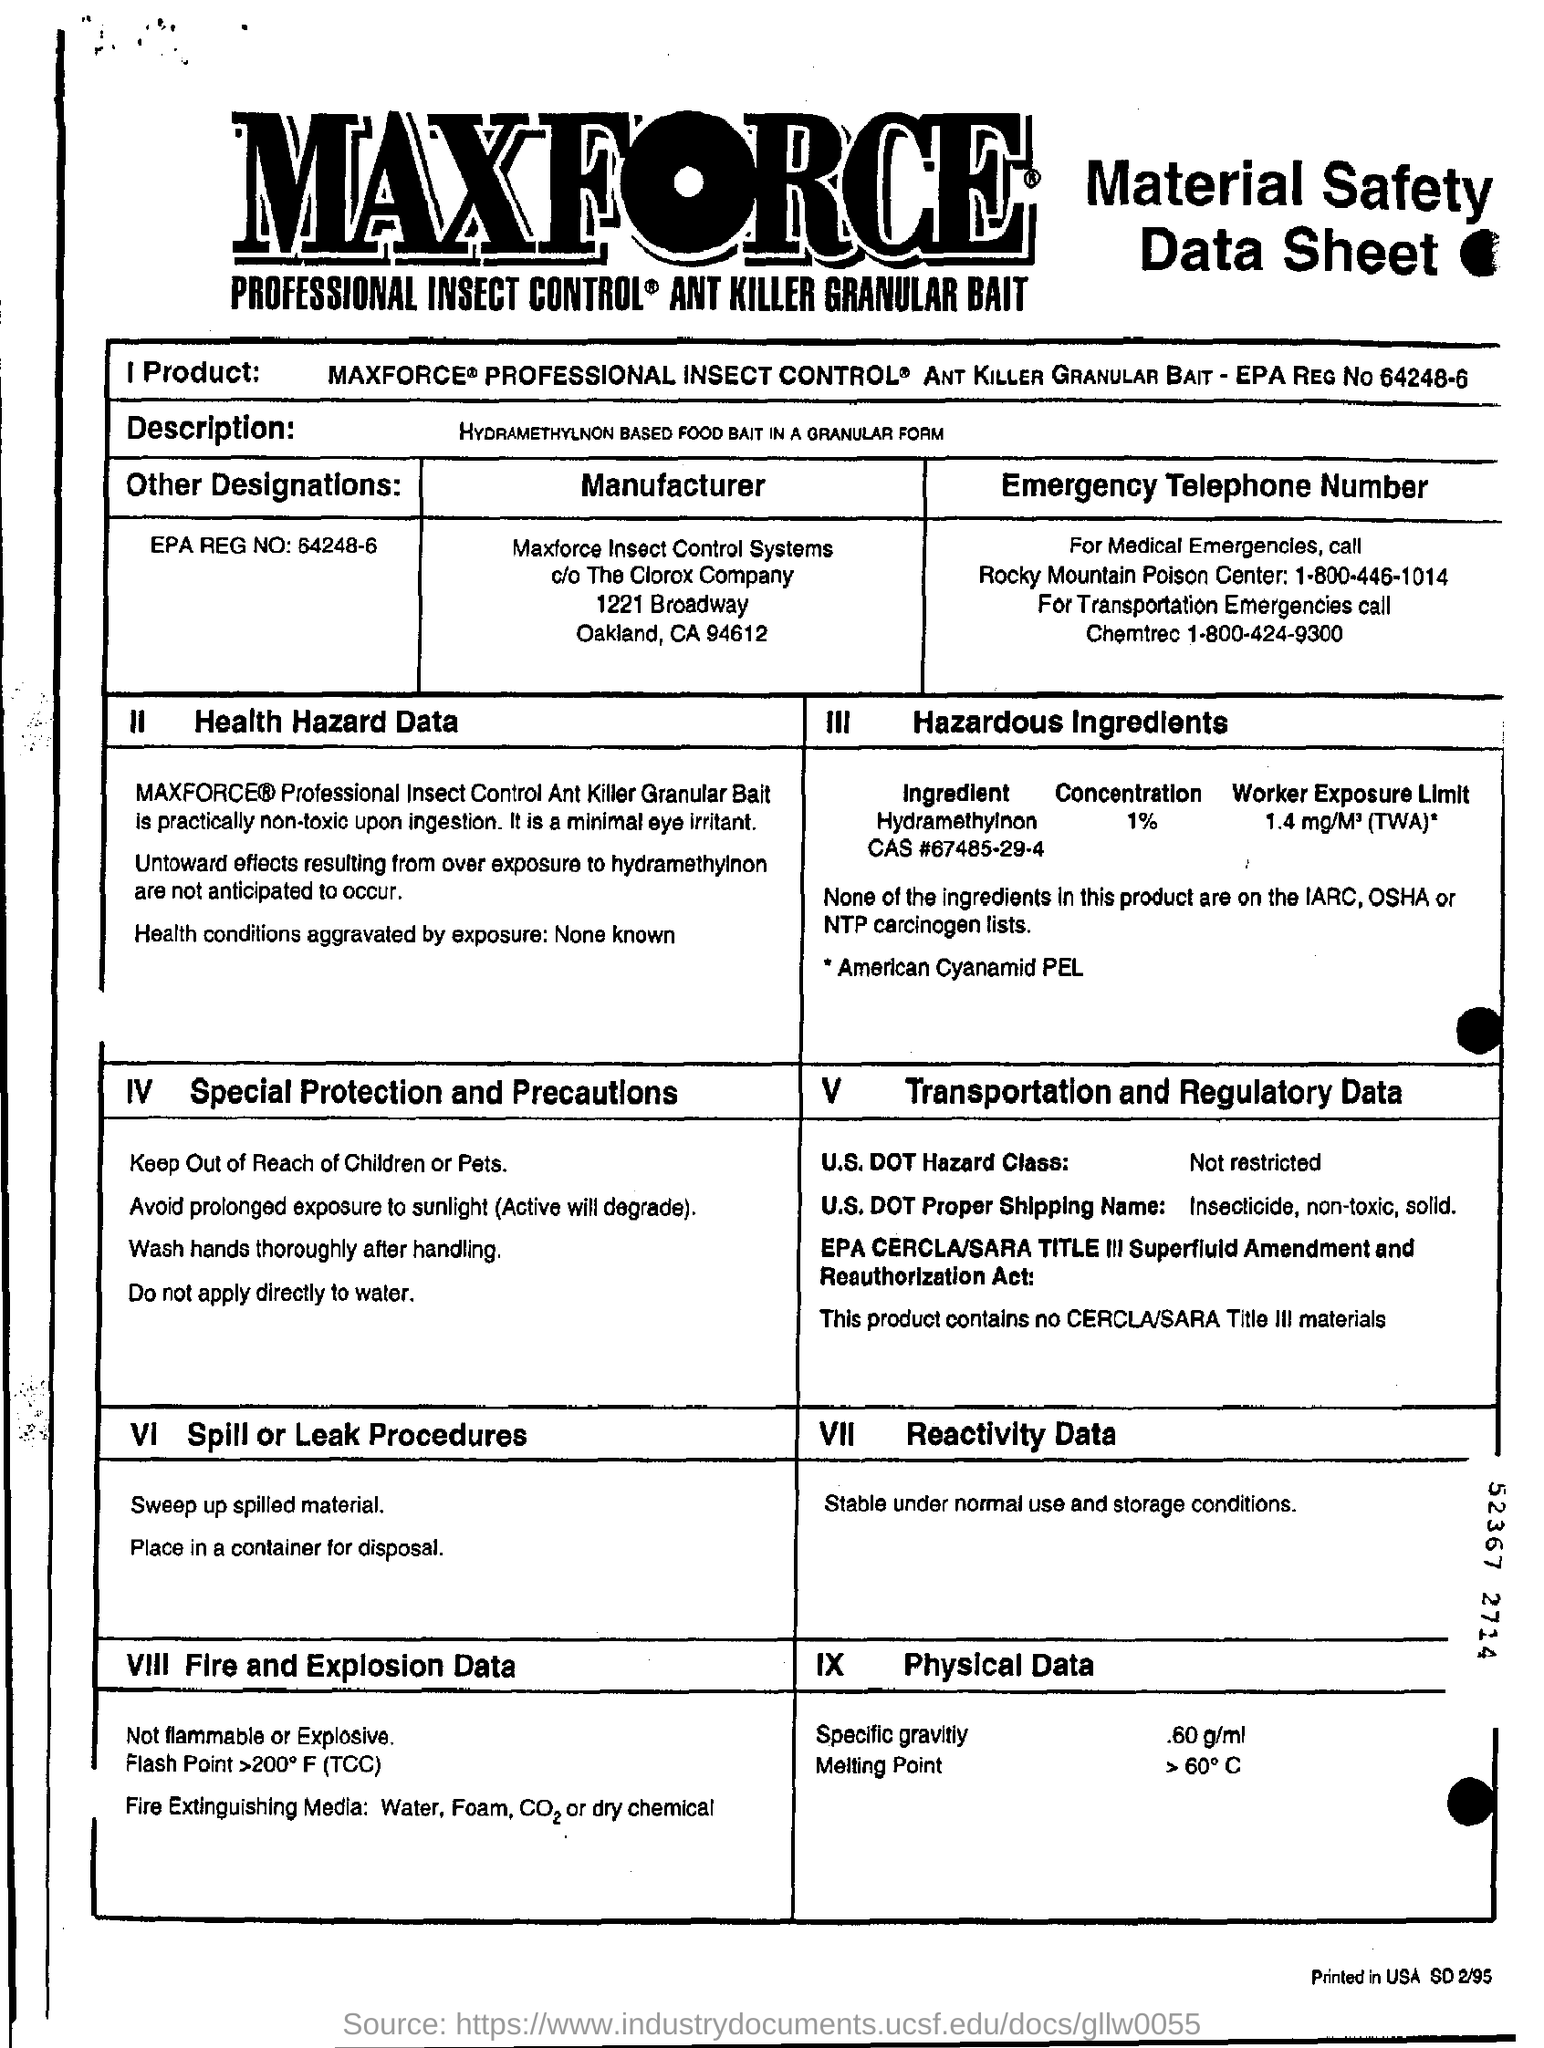Specify some key components in this picture. The specific gravity of a liquid with a physical data of 0.60 g/mL is 0.60. The United States Department of Transportation (DOT) Hazard Class indicates that a substance is not restricted. The Proper Shipping Name for a solid, non-toxic insecticide listed in section V is [U.S. DOT]. 